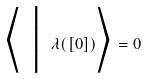<formula> <loc_0><loc_0><loc_500><loc_500>\Big \langle \ \Big | \ \lambda ( [ 0 ] ) \Big \rangle = 0</formula> 